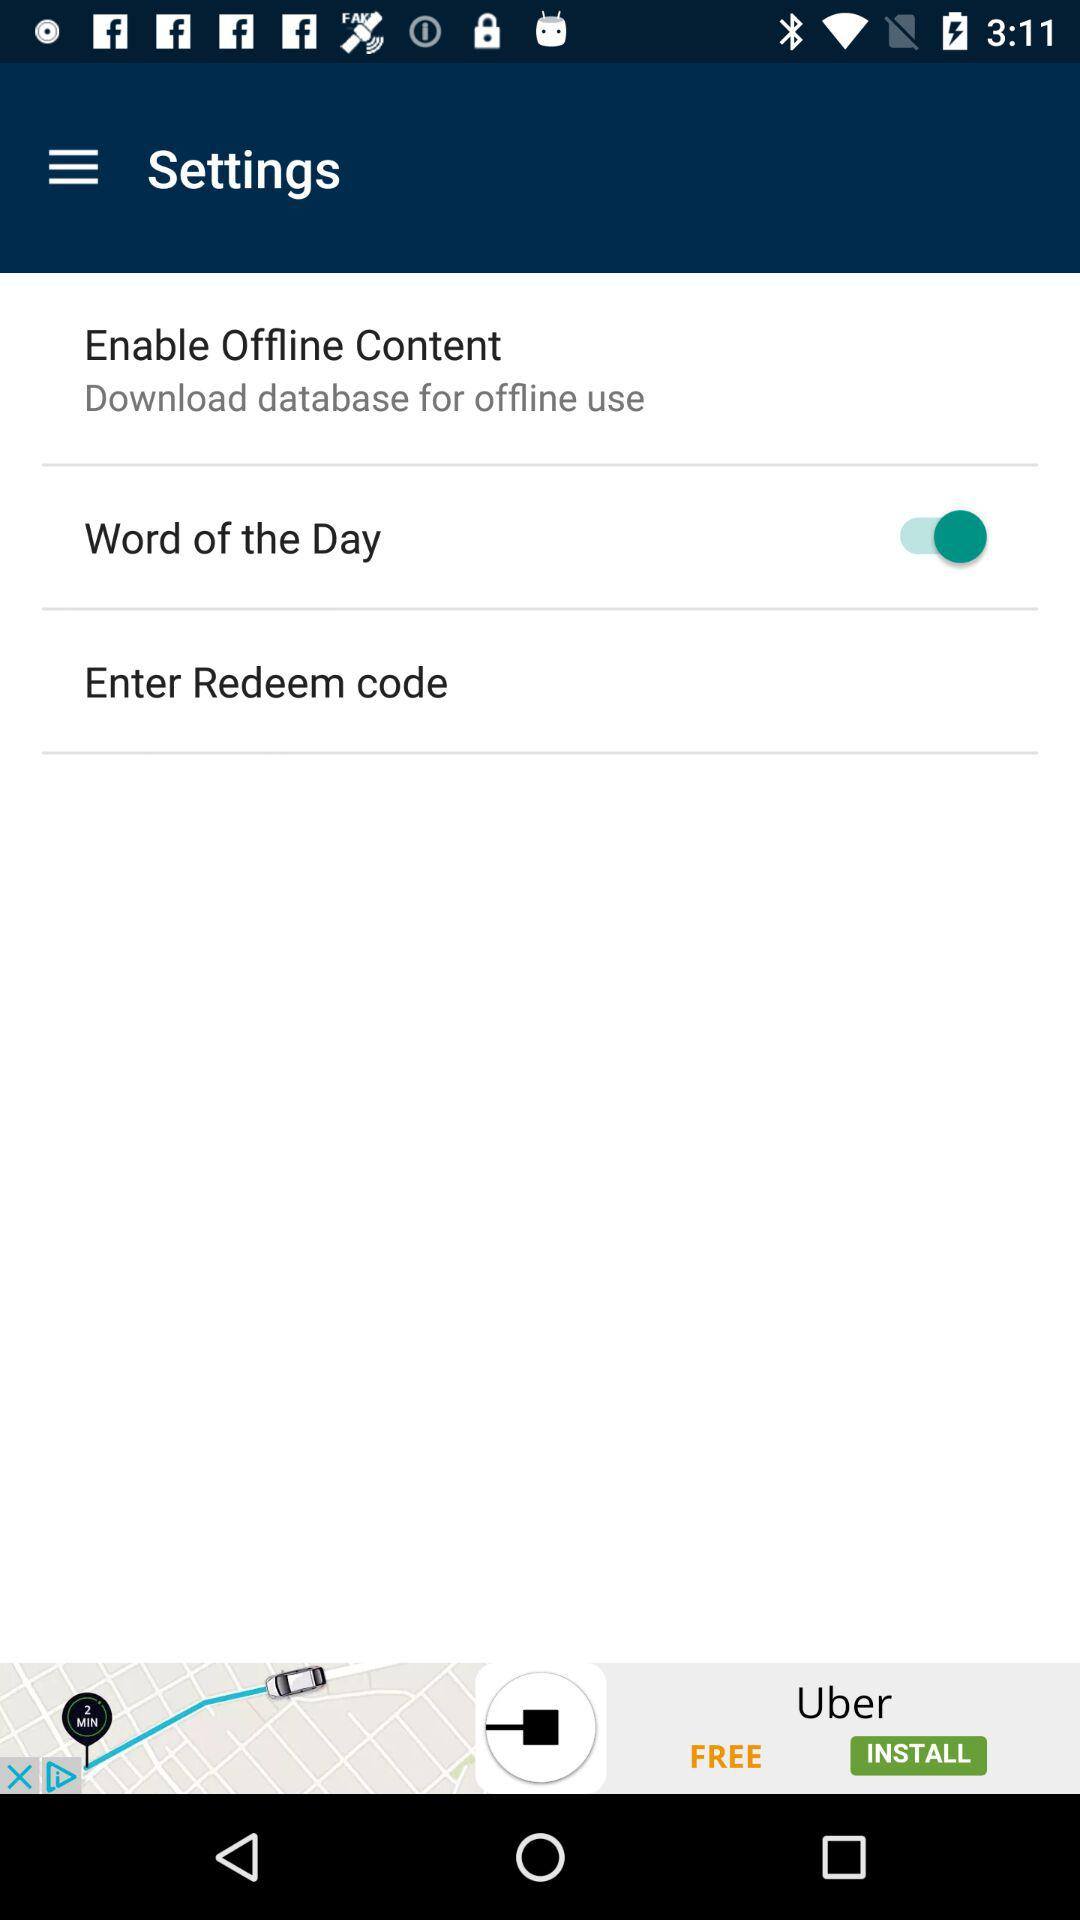What is the status of the "Word of the Day"? The status is "on". 